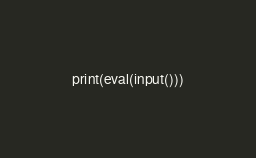<code> <loc_0><loc_0><loc_500><loc_500><_Python_>print(eval(input()))</code> 